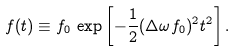Convert formula to latex. <formula><loc_0><loc_0><loc_500><loc_500>f ( t ) \equiv f _ { 0 } \, \exp \left [ - \frac { 1 } { 2 } ( \Delta \omega f _ { 0 } ) ^ { 2 } t ^ { 2 } \right ] .</formula> 